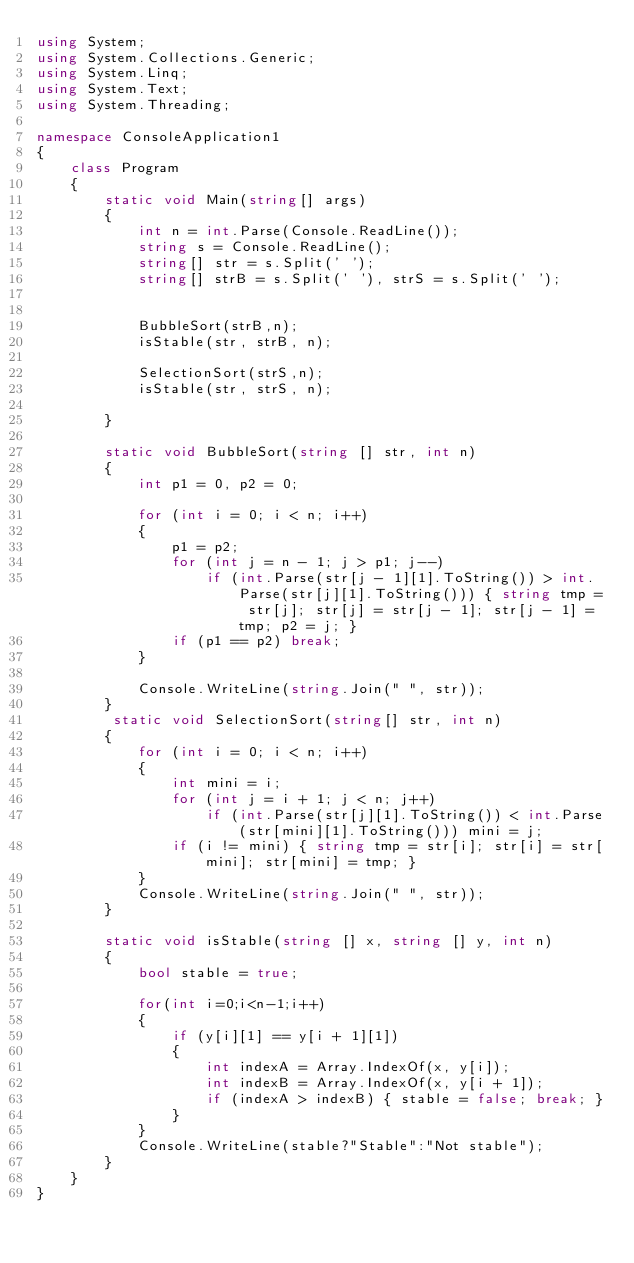<code> <loc_0><loc_0><loc_500><loc_500><_C#_>using System;
using System.Collections.Generic;
using System.Linq;
using System.Text;
using System.Threading;

namespace ConsoleApplication1
{
    class Program
    {
        static void Main(string[] args)
        {
            int n = int.Parse(Console.ReadLine());
            string s = Console.ReadLine();
            string[] str = s.Split(' ');
            string[] strB = s.Split(' '), strS = s.Split(' ');


            BubbleSort(strB,n);
            isStable(str, strB, n);

            SelectionSort(strS,n);
            isStable(str, strS, n);

        }

        static void BubbleSort(string [] str, int n)
        {
            int p1 = 0, p2 = 0;

            for (int i = 0; i < n; i++)
            {
                p1 = p2;
                for (int j = n - 1; j > p1; j--)
                    if (int.Parse(str[j - 1][1].ToString()) > int.Parse(str[j][1].ToString())) { string tmp = str[j]; str[j] = str[j - 1]; str[j - 1] = tmp; p2 = j; }
                if (p1 == p2) break;
            }

            Console.WriteLine(string.Join(" ", str));
        }
         static void SelectionSort(string[] str, int n)
        {
            for (int i = 0; i < n; i++)
            {
                int mini = i;
                for (int j = i + 1; j < n; j++)
                    if (int.Parse(str[j][1].ToString()) < int.Parse(str[mini][1].ToString())) mini = j;
                if (i != mini) { string tmp = str[i]; str[i] = str[mini]; str[mini] = tmp; }
            }
            Console.WriteLine(string.Join(" ", str));
        }

        static void isStable(string [] x, string [] y, int n)
        {
            bool stable = true;

            for(int i=0;i<n-1;i++)
            {
                if (y[i][1] == y[i + 1][1])
                {
                    int indexA = Array.IndexOf(x, y[i]);
                    int indexB = Array.IndexOf(x, y[i + 1]);
                    if (indexA > indexB) { stable = false; break; }
                }
            }
            Console.WriteLine(stable?"Stable":"Not stable");
        }
    }
}</code> 